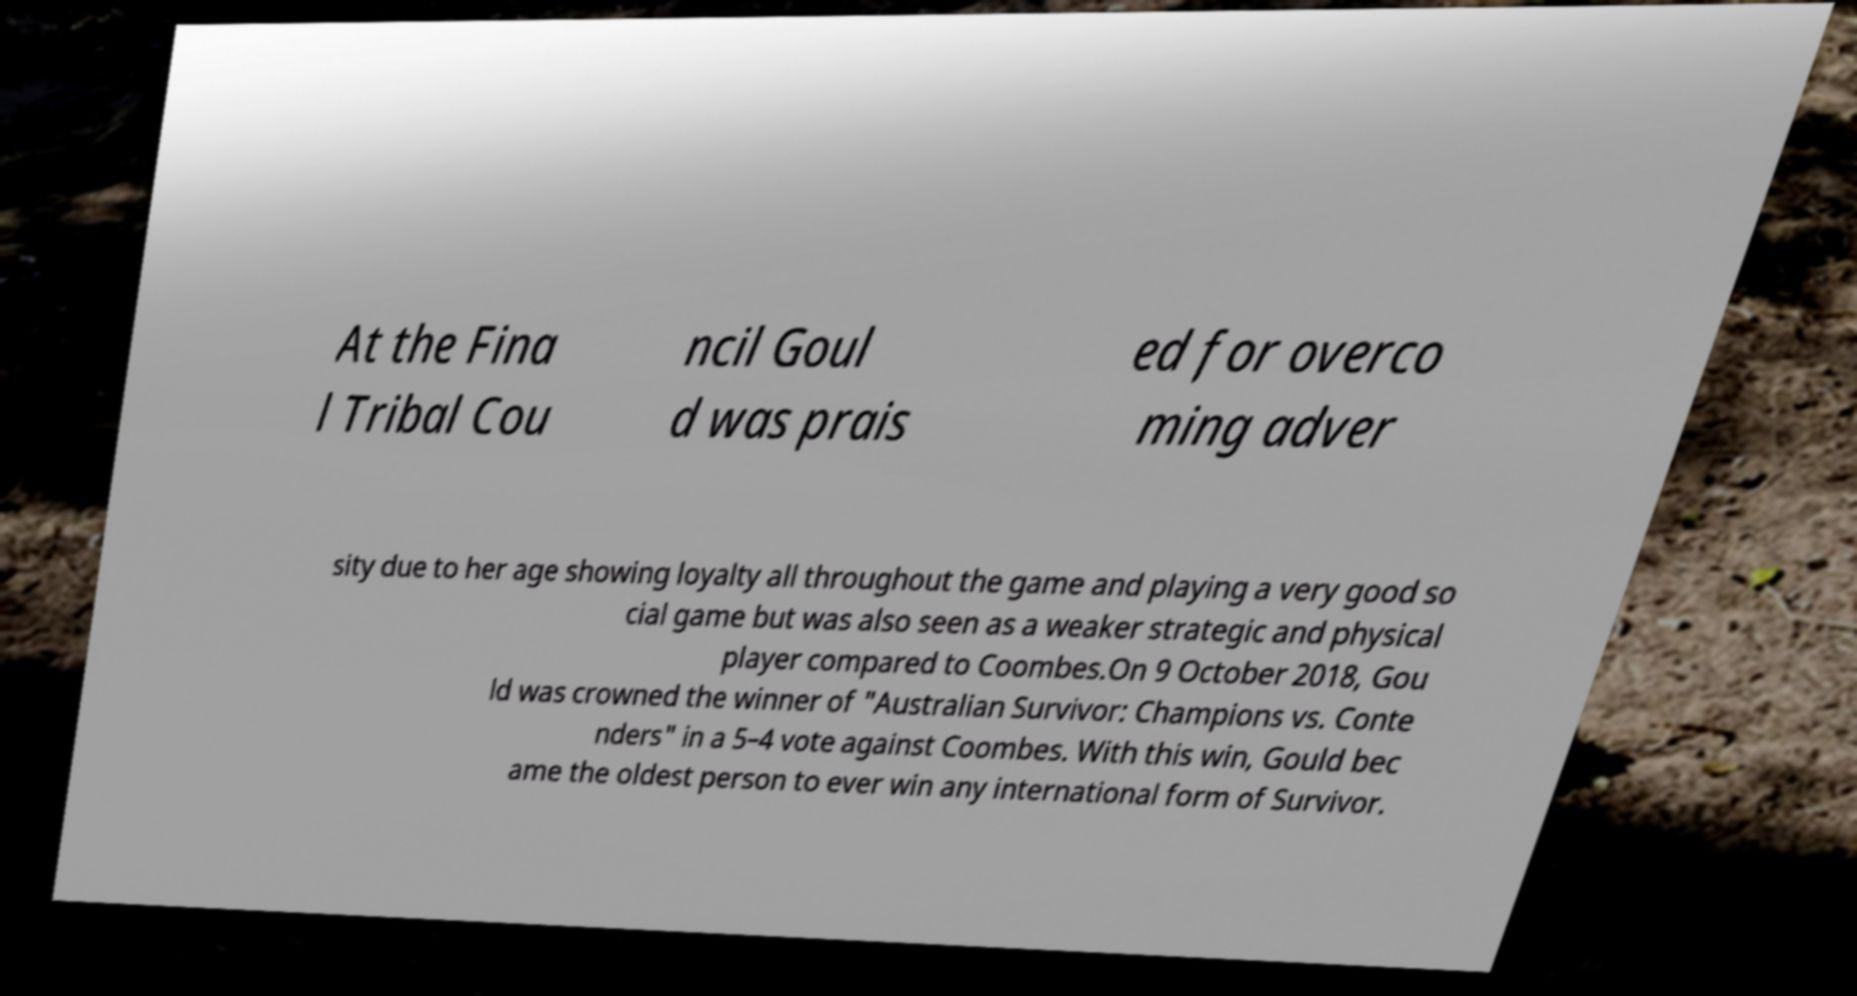I need the written content from this picture converted into text. Can you do that? At the Fina l Tribal Cou ncil Goul d was prais ed for overco ming adver sity due to her age showing loyalty all throughout the game and playing a very good so cial game but was also seen as a weaker strategic and physical player compared to Coombes.On 9 October 2018, Gou ld was crowned the winner of "Australian Survivor: Champions vs. Conte nders" in a 5–4 vote against Coombes. With this win, Gould bec ame the oldest person to ever win any international form of Survivor. 